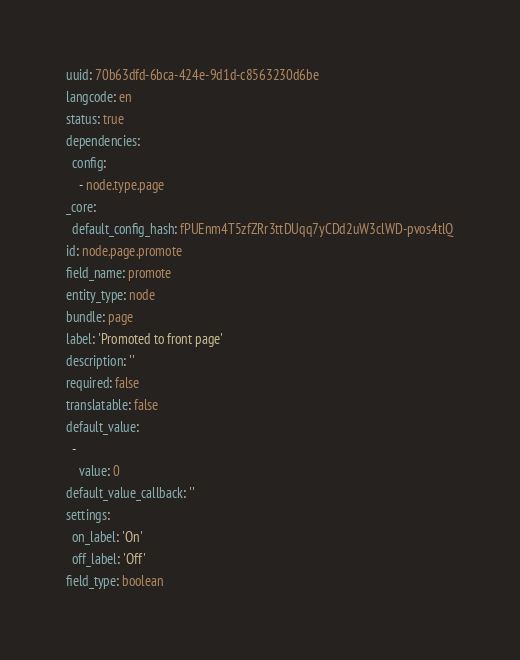<code> <loc_0><loc_0><loc_500><loc_500><_YAML_>uuid: 70b63dfd-6bca-424e-9d1d-c8563230d6be
langcode: en
status: true
dependencies:
  config:
    - node.type.page
_core:
  default_config_hash: fPUEnm4T5zfZRr3ttDUqq7yCDd2uW3clWD-pvos4tlQ
id: node.page.promote
field_name: promote
entity_type: node
bundle: page
label: 'Promoted to front page'
description: ''
required: false
translatable: false
default_value:
  -
    value: 0
default_value_callback: ''
settings:
  on_label: 'On'
  off_label: 'Off'
field_type: boolean
</code> 